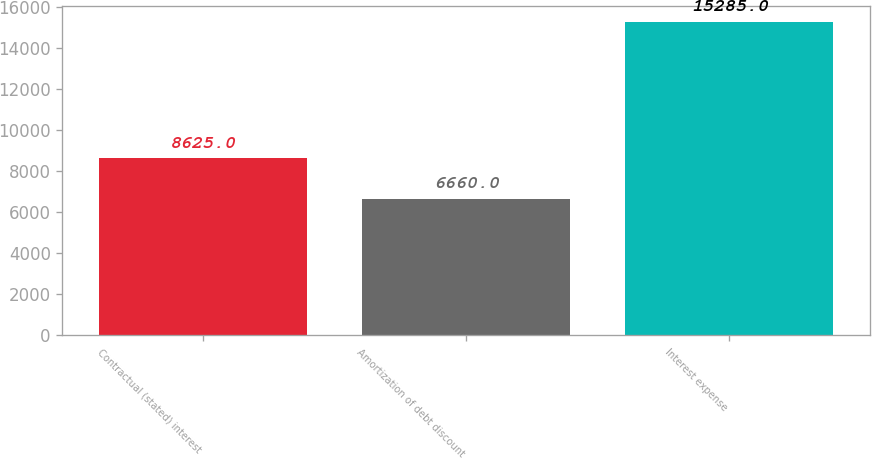<chart> <loc_0><loc_0><loc_500><loc_500><bar_chart><fcel>Contractual (stated) interest<fcel>Amortization of debt discount<fcel>Interest expense<nl><fcel>8625<fcel>6660<fcel>15285<nl></chart> 